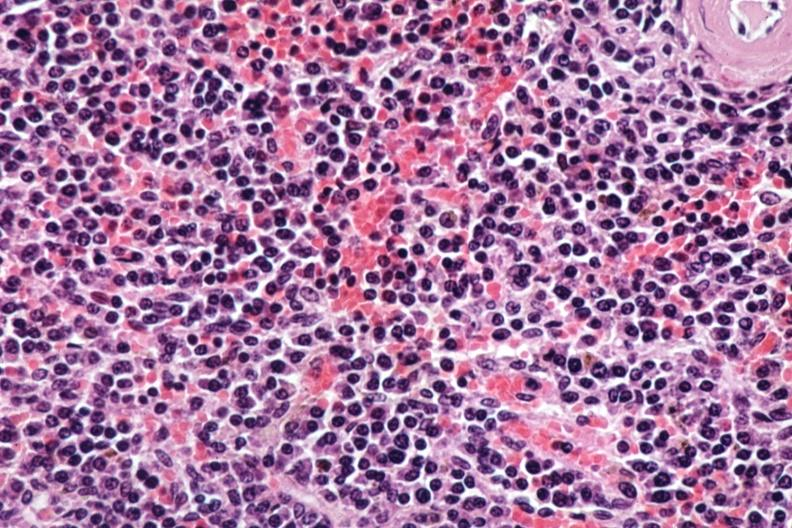s spleen present?
Answer the question using a single word or phrase. Yes 